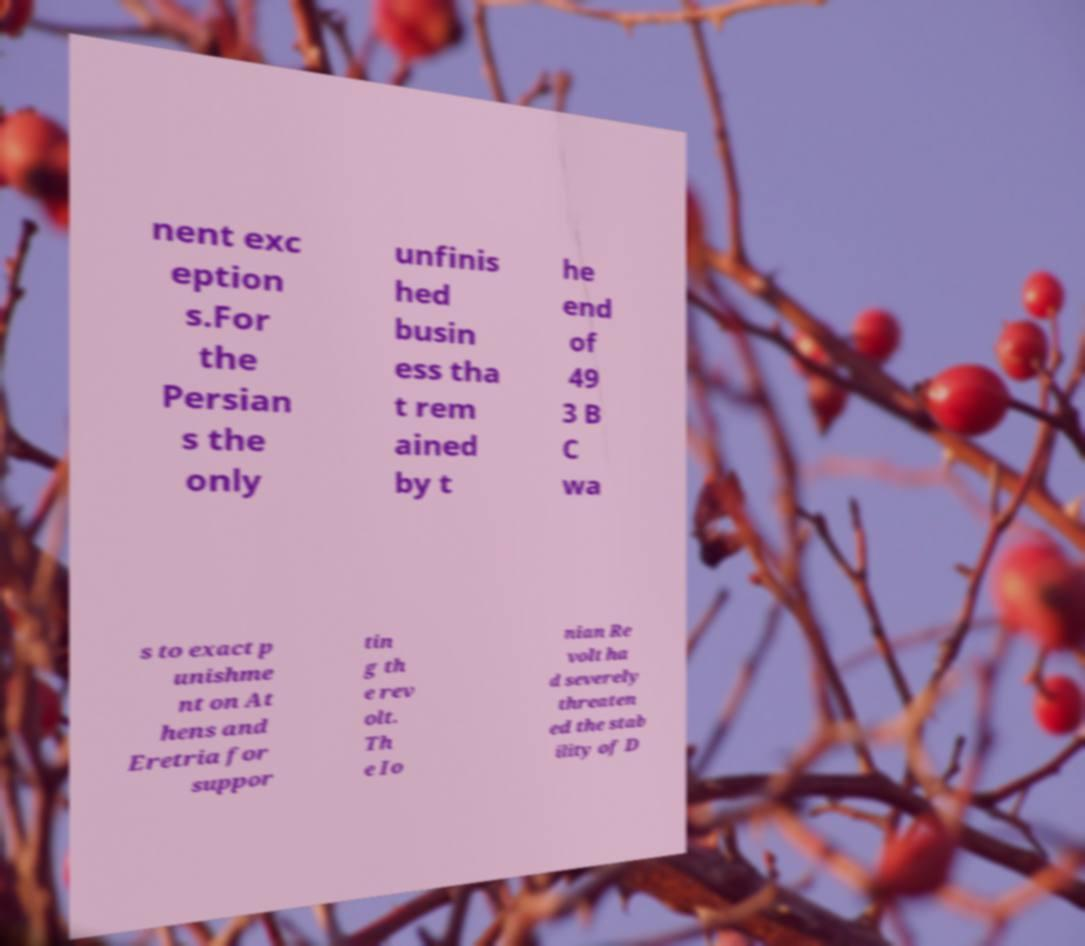I need the written content from this picture converted into text. Can you do that? nent exc eption s.For the Persian s the only unfinis hed busin ess tha t rem ained by t he end of 49 3 B C wa s to exact p unishme nt on At hens and Eretria for suppor tin g th e rev olt. Th e Io nian Re volt ha d severely threaten ed the stab ility of D 